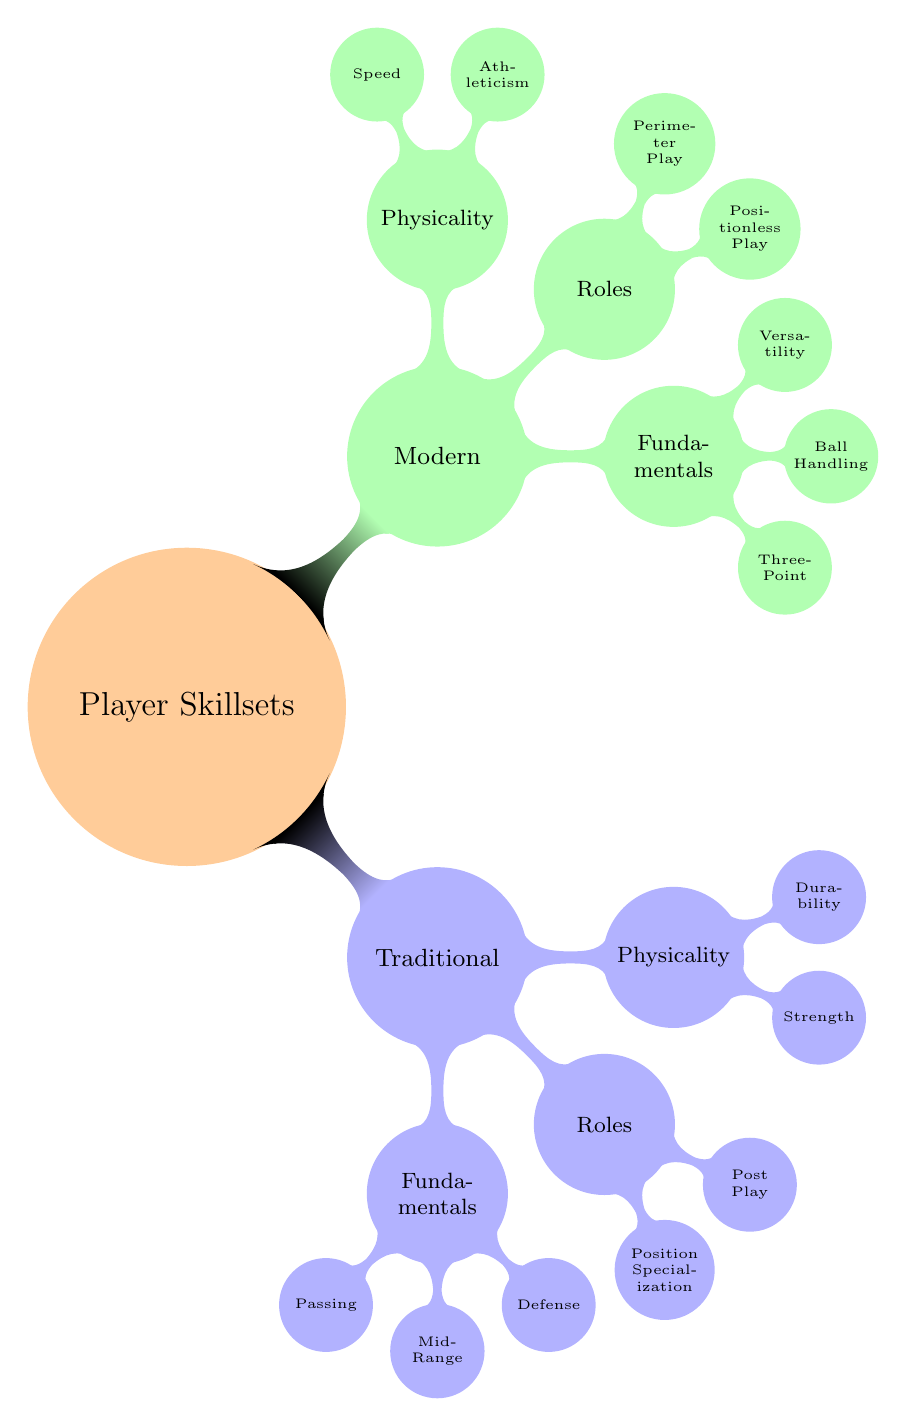What are the three fundamental skills listed under Traditional Basketball? The diagram shows that the three fundamental skills under Traditional Basketball are Passing, Mid-Range Shooting, and Defense. This can be found in the "Fundamentals" section of the "Traditional Basketball" branch.
Answer: Passing, Mid-Range Shooting, Defense Who is associated with Mid-Range Shooting in Traditional Basketball? According to the diagram, the node under Mid-Range Shooting states "Larry Bird" as the associated player. This information is explicitly noted under the "Fundamentals" section of the "Traditional Basketball" category.
Answer: Larry Bird How many roles are highlighted in Modern Basketball? The diagram indicates that there are two roles highlighted in Modern Basketball: Positionless Play and Perimeter Play. This can be seen in the "Roles" section under the "Modern Basketball" branch.
Answer: 2 Which player represents the concept of Strength in Traditional Basketball? The diagram clearly indicates "Charles Oakley" under the Physicality section of Traditional Basketball, representing the concept of Strength. This connect can be directly followed from the "Physicality" node.
Answer: Charles Oakley What type of play is associated with Giannis Antetokounmpo in Modern Basketball? The Mind Map specifies that Giannis Antetokounmpo is associated with the concept of Positionless Play, listed under the "Roles" section of Modern Basketball. This is a direct correlation from the surrounding nodes.
Answer: Positionless Play Which skill is represented by Stephen Curry in Modern Basketball? The diagram states that Stephen Curry is associated with Three-Point Shooting, which is listed under the "Fundamentals" section of Modern Basketball. This is detailed in the corresponding node under that category.
Answer: Three-Point Shooting What is the primary difference in physicality between the two basketball styles? By examining the Physicality sections, Traditional Basketball emphasizes Strength and Durability, while Modern Basketball focuses on Athleticism and Speed. Thus, the primary difference is in the focus on strength versus agility.
Answer: Strength vs. Athleticism What role is associated with Kevin Durant in Modern Basketball? The diagram shows that Kevin Durant is associated with Perimeter Play, which falls under the "Roles" section of Modern Basketball. This relationship is evident by directly referencing the node.
Answer: Perimeter Play 